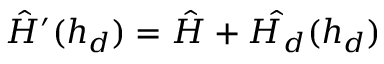<formula> <loc_0><loc_0><loc_500><loc_500>\hat { H } ^ { \prime } ( h _ { d } ) = \hat { H } + \hat { H _ { d } } ( h _ { d } )</formula> 